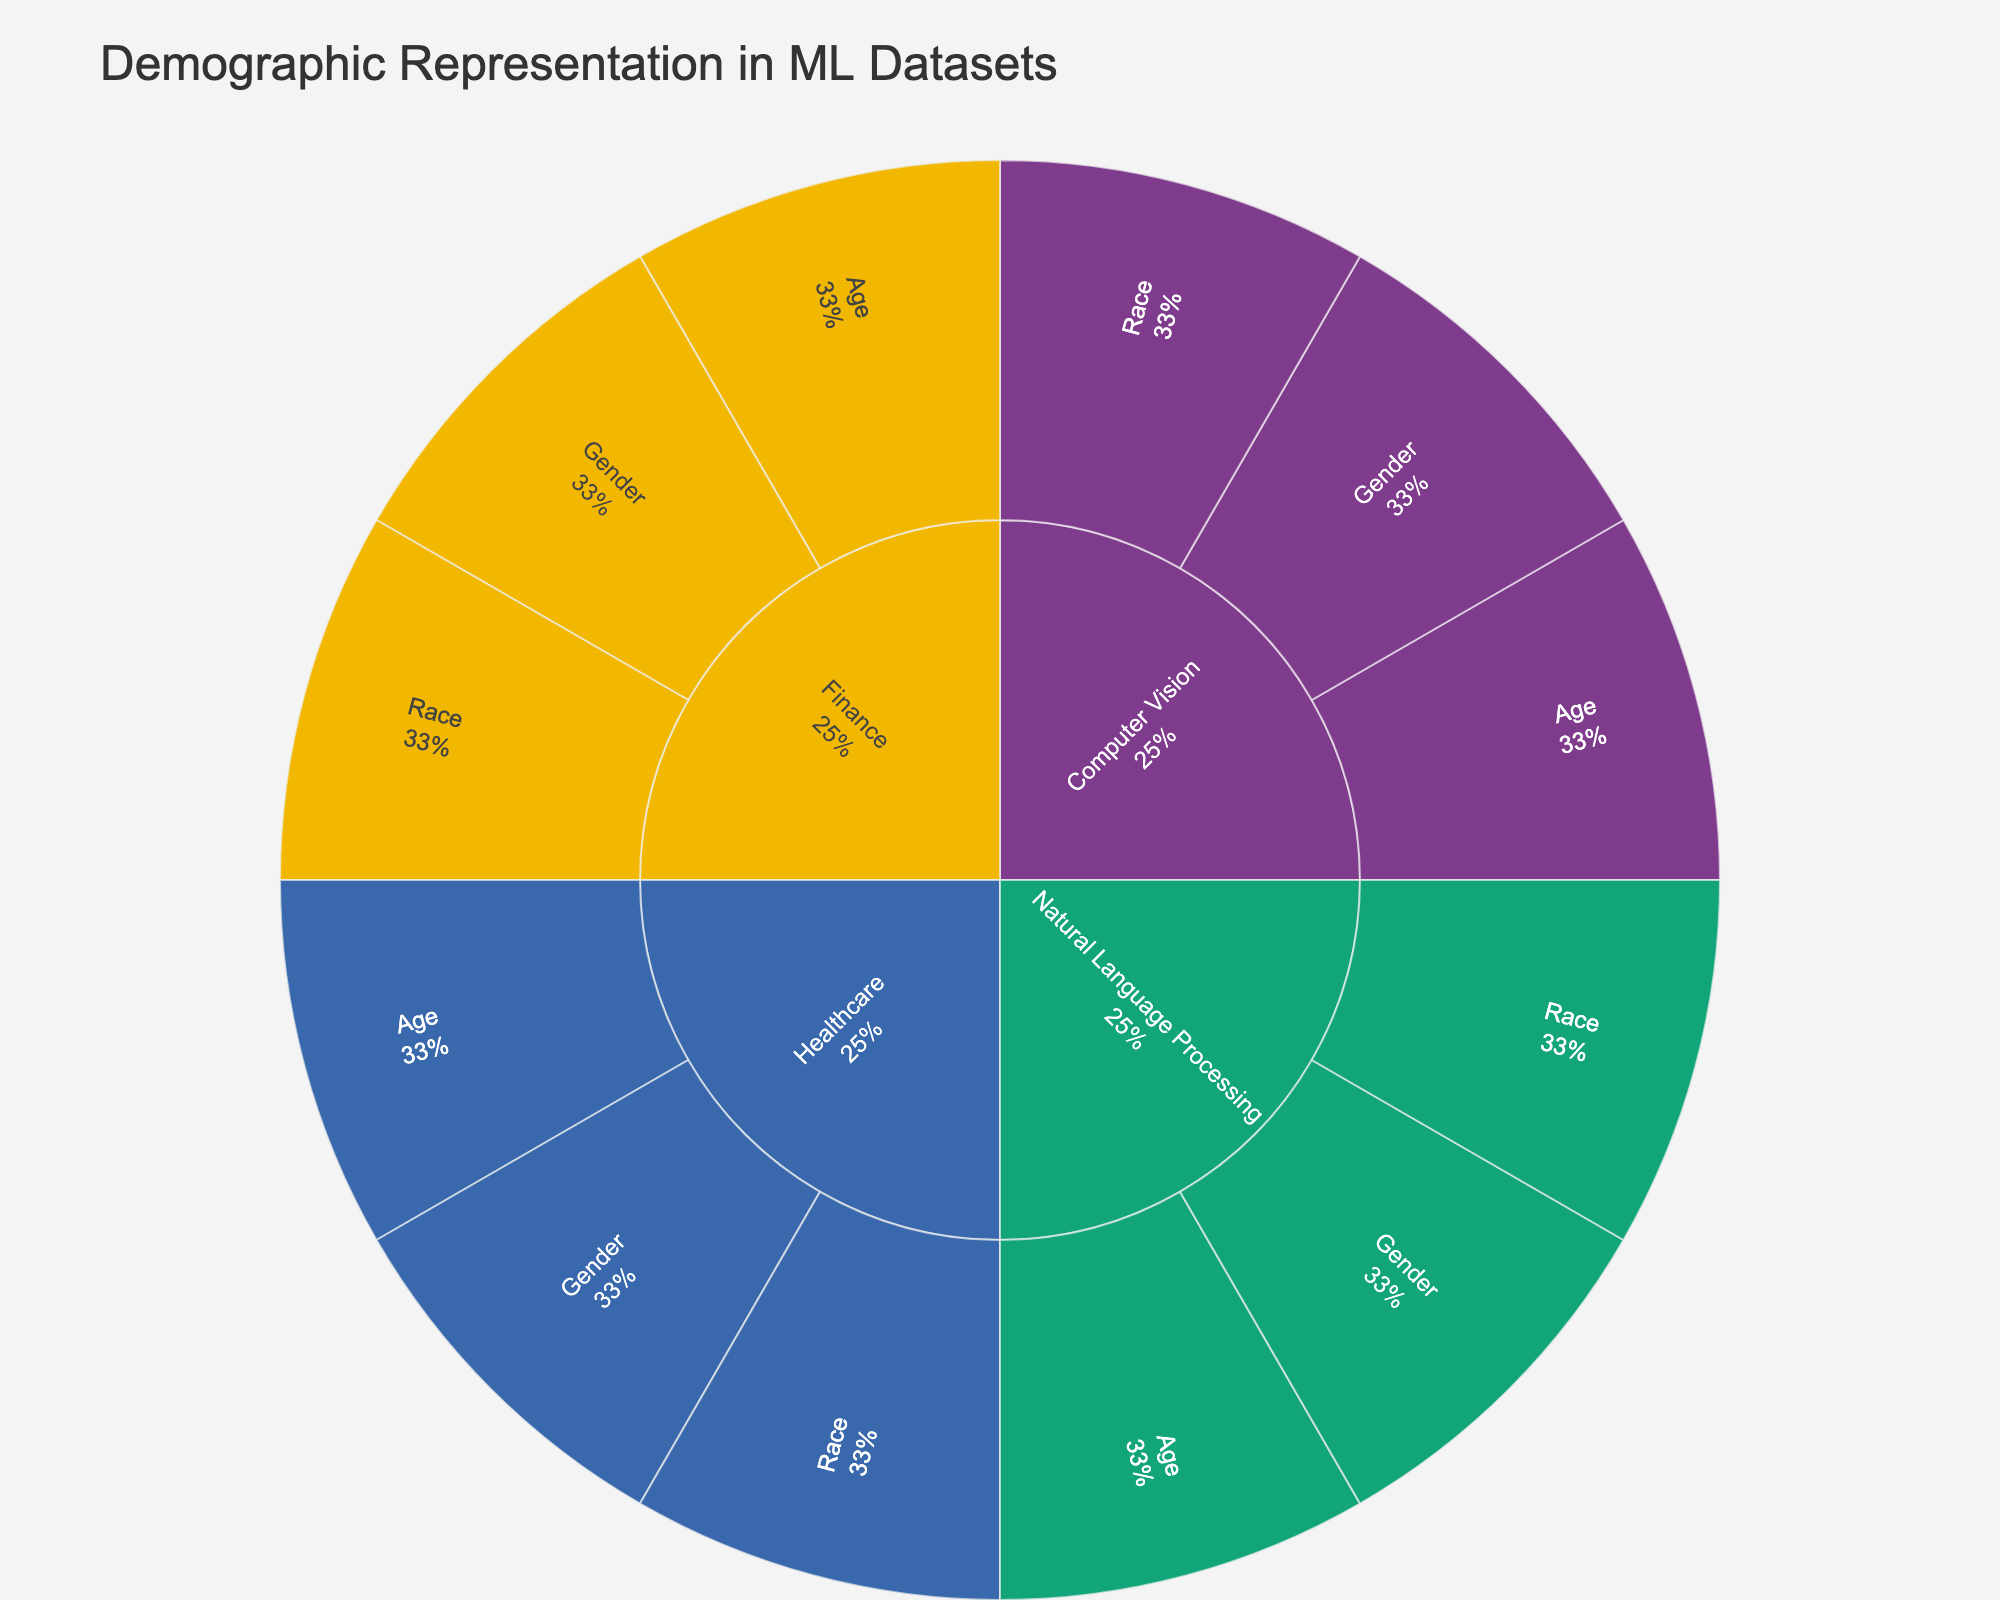Which domain has the highest representation of males? To find the domain with the highest male representation, locate the 'Gender' category under each domain and compare the male percentages. Natural Language Processing has the highest representation with 55%.
Answer: Natural Language Processing What is the combined percentage of the 'Asian' subgroup across all domains? Locate the 'Asian' subgroups within the 'Race' category for each domain and sum their percentages. The combined value is 20% (Computer Vision) + 15% (Natural Language Processing) + 15% (Healthcare) + 15% (Finance) = 65%.
Answer: 65% Which age group has the highest representation in the Healthcare domain? Navigate to the Healthcare domain, find the 'Age' category, and compare the values for the subcategories 18-30, 31-50, and 51+. The group 51+ has the highest representation with 45%.
Answer: 51+ Compare the representation of 'Non-binary' gender across Finance and Computer Vision domains. Which one has a higher value? Identify the 'Non-binary' values under the 'Gender' category for both Finance (5%) and Computer Vision (15%). Computer Vision has a higher representation.
Answer: Computer Vision What is the title of the figure? The title is usually placed at the top center of the figure. For this sunburst plot, the title is "Demographic Representation in ML Datasets".
Answer: Demographic Representation in ML Datasets Which domain shows the highest diversity in age groups (considering more even distribution across age subcategories)? Consider the distribution of percentages across the 'Age' category in each domain. Computer Vision has a relatively even distribution (30%, 40%, 30%), more so than the other domains.
Answer: Computer Vision Which domain has the lowest percentage of the 'Black' race? Navigate to the 'Race' category under each domain and compare the percentages for the 'Black' subcategory. Finance has the lowest representation with 8%.
Answer: Finance What is the combined percentage of the 'Female' gender in Computer Vision and Healthcare domains? Find the 'Female' subcategories under the 'Gender' category in both domains and sum their percentages. The combined value is 40% (Computer Vision) + 50% (Healthcare) = 90%.
Answer: 90% Which domain has the highest average representation for all its subcategories within the 'Age' category? Calculate the average representation by summing the percentages in the 'Age' category for each domain, then divide by the number of subcategories (three). For example, for Finance: (15% + 50% + 35%) = 100%, and the average is 100% / 3 = 33.33%. Compare these averages across domains, with Finance having the highest at 33.33%.
Answer: Finance 